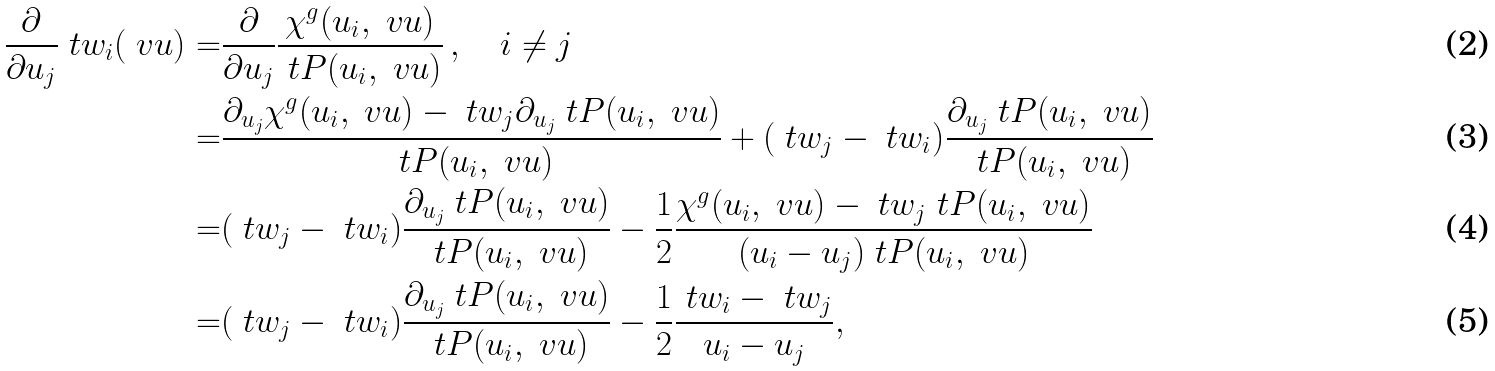<formula> <loc_0><loc_0><loc_500><loc_500>\frac { \partial } { \partial u _ { j } } \ t w _ { i } ( \ v u ) = & \frac { \partial } { \partial u _ { j } } \frac { \chi ^ { g } ( u _ { i } , \ v u ) } { \ t P ( u _ { i } , \ v u ) } \, , \quad i \neq j \\ = & \frac { \partial _ { u _ { j } } \chi ^ { g } ( u _ { i } , \ v u ) - \ t w _ { j } \partial _ { u _ { j } } \ t P ( u _ { i } , \ v u ) } { \ t P ( u _ { i } , \ v u ) } + ( \ t w _ { j } - \ t w _ { i } ) \frac { \partial _ { u _ { j } } \ t P ( u _ { i } , \ v u ) } { \ t P ( u _ { i } , \ v u ) } \\ = & ( \ t w _ { j } - \ t w _ { i } ) \frac { \partial _ { u _ { j } } \ t P ( u _ { i } , \ v u ) } { \ t P ( u _ { i } , \ v u ) } - \frac { 1 } { 2 } \frac { \chi ^ { g } ( u _ { i } , \ v u ) - \ t w _ { j } \ t P ( u _ { i } , \ v u ) } { ( u _ { i } - u _ { j } ) \ t P ( u _ { i } , \ v u ) } \\ = & ( \ t w _ { j } - \ t w _ { i } ) \frac { \partial _ { u _ { j } } \ t P ( u _ { i } , \ v u ) } { \ t P ( u _ { i } , \ v u ) } - \frac { 1 } { 2 } \frac { \ t w _ { i } - \ t w _ { j } } { u _ { i } - u _ { j } } ,</formula> 